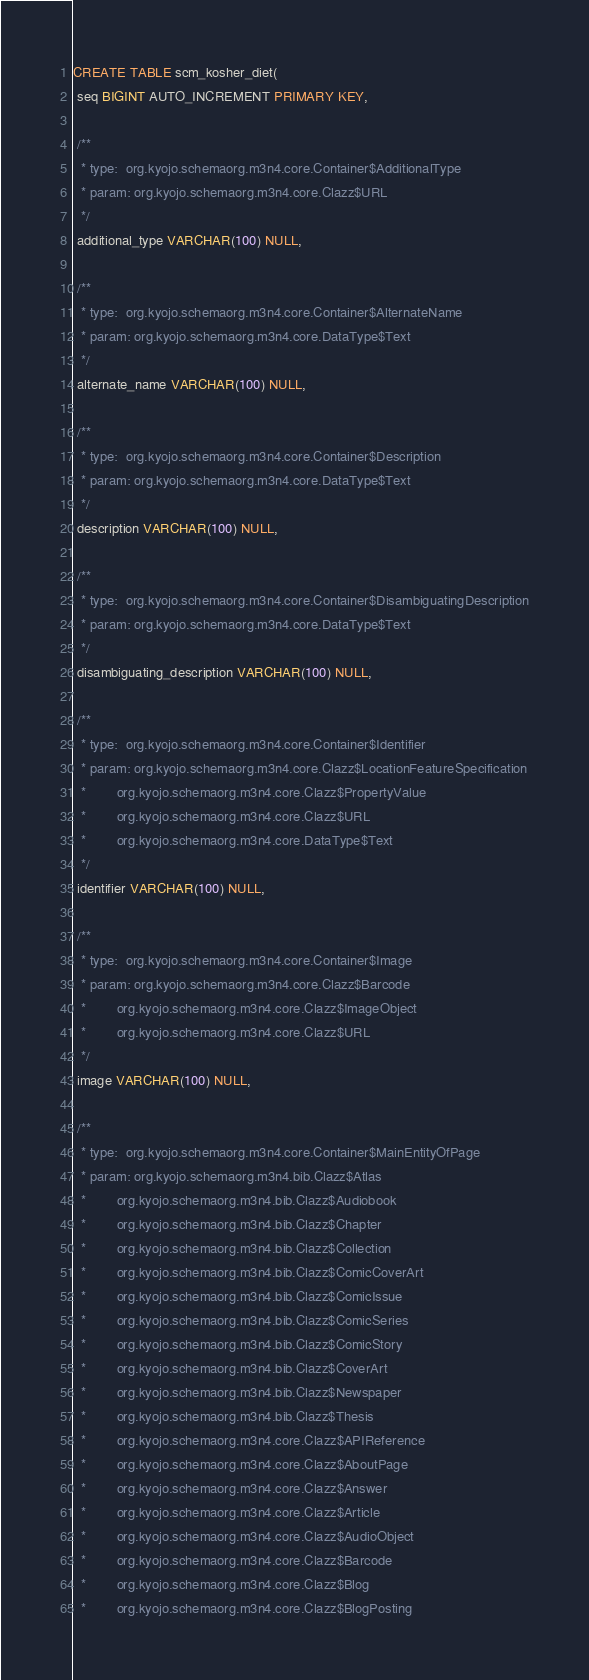Convert code to text. <code><loc_0><loc_0><loc_500><loc_500><_SQL_>CREATE TABLE scm_kosher_diet(
 seq BIGINT AUTO_INCREMENT PRIMARY KEY,

 /**
  * type:  org.kyojo.schemaorg.m3n4.core.Container$AdditionalType
  * param: org.kyojo.schemaorg.m3n4.core.Clazz$URL
  */
 additional_type VARCHAR(100) NULL,

 /**
  * type:  org.kyojo.schemaorg.m3n4.core.Container$AlternateName
  * param: org.kyojo.schemaorg.m3n4.core.DataType$Text
  */
 alternate_name VARCHAR(100) NULL,

 /**
  * type:  org.kyojo.schemaorg.m3n4.core.Container$Description
  * param: org.kyojo.schemaorg.m3n4.core.DataType$Text
  */
 description VARCHAR(100) NULL,

 /**
  * type:  org.kyojo.schemaorg.m3n4.core.Container$DisambiguatingDescription
  * param: org.kyojo.schemaorg.m3n4.core.DataType$Text
  */
 disambiguating_description VARCHAR(100) NULL,

 /**
  * type:  org.kyojo.schemaorg.m3n4.core.Container$Identifier
  * param: org.kyojo.schemaorg.m3n4.core.Clazz$LocationFeatureSpecification
  *        org.kyojo.schemaorg.m3n4.core.Clazz$PropertyValue
  *        org.kyojo.schemaorg.m3n4.core.Clazz$URL
  *        org.kyojo.schemaorg.m3n4.core.DataType$Text
  */
 identifier VARCHAR(100) NULL,

 /**
  * type:  org.kyojo.schemaorg.m3n4.core.Container$Image
  * param: org.kyojo.schemaorg.m3n4.core.Clazz$Barcode
  *        org.kyojo.schemaorg.m3n4.core.Clazz$ImageObject
  *        org.kyojo.schemaorg.m3n4.core.Clazz$URL
  */
 image VARCHAR(100) NULL,

 /**
  * type:  org.kyojo.schemaorg.m3n4.core.Container$MainEntityOfPage
  * param: org.kyojo.schemaorg.m3n4.bib.Clazz$Atlas
  *        org.kyojo.schemaorg.m3n4.bib.Clazz$Audiobook
  *        org.kyojo.schemaorg.m3n4.bib.Clazz$Chapter
  *        org.kyojo.schemaorg.m3n4.bib.Clazz$Collection
  *        org.kyojo.schemaorg.m3n4.bib.Clazz$ComicCoverArt
  *        org.kyojo.schemaorg.m3n4.bib.Clazz$ComicIssue
  *        org.kyojo.schemaorg.m3n4.bib.Clazz$ComicSeries
  *        org.kyojo.schemaorg.m3n4.bib.Clazz$ComicStory
  *        org.kyojo.schemaorg.m3n4.bib.Clazz$CoverArt
  *        org.kyojo.schemaorg.m3n4.bib.Clazz$Newspaper
  *        org.kyojo.schemaorg.m3n4.bib.Clazz$Thesis
  *        org.kyojo.schemaorg.m3n4.core.Clazz$APIReference
  *        org.kyojo.schemaorg.m3n4.core.Clazz$AboutPage
  *        org.kyojo.schemaorg.m3n4.core.Clazz$Answer
  *        org.kyojo.schemaorg.m3n4.core.Clazz$Article
  *        org.kyojo.schemaorg.m3n4.core.Clazz$AudioObject
  *        org.kyojo.schemaorg.m3n4.core.Clazz$Barcode
  *        org.kyojo.schemaorg.m3n4.core.Clazz$Blog
  *        org.kyojo.schemaorg.m3n4.core.Clazz$BlogPosting</code> 